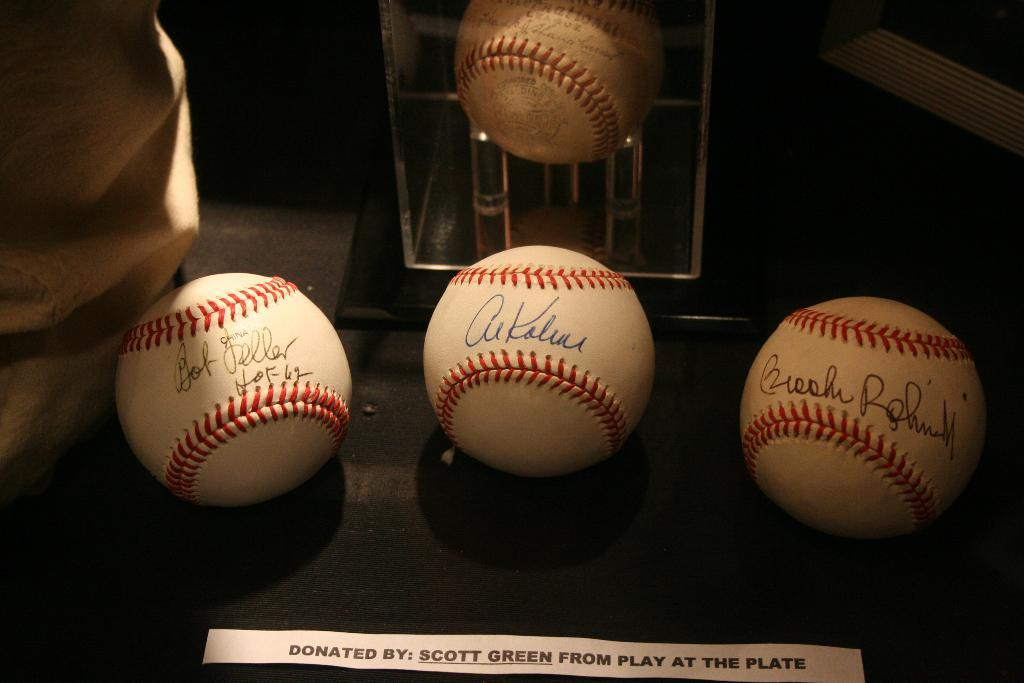<image>
Describe the image concisely. Baseballs with signatures, donated by Scott Green from Play at the Plate. 